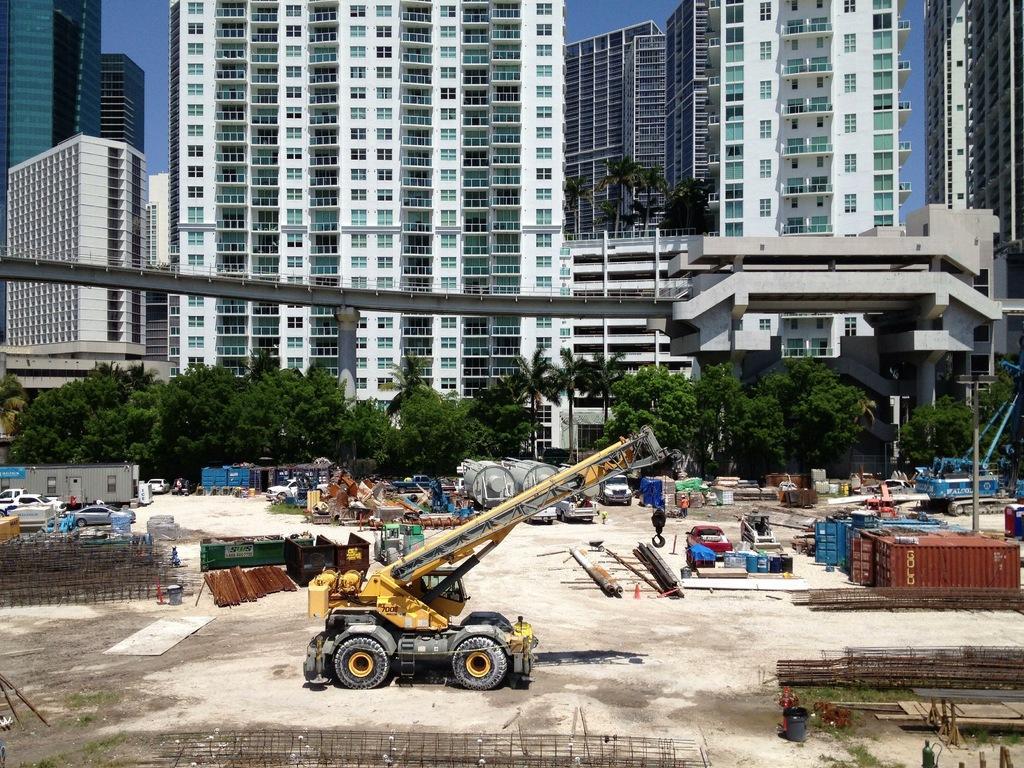Please provide a concise description of this image. In this image we can see a crane, metal rods, containers, vehicles, trees. In the background of the image there are buildings, bridge and sky. 